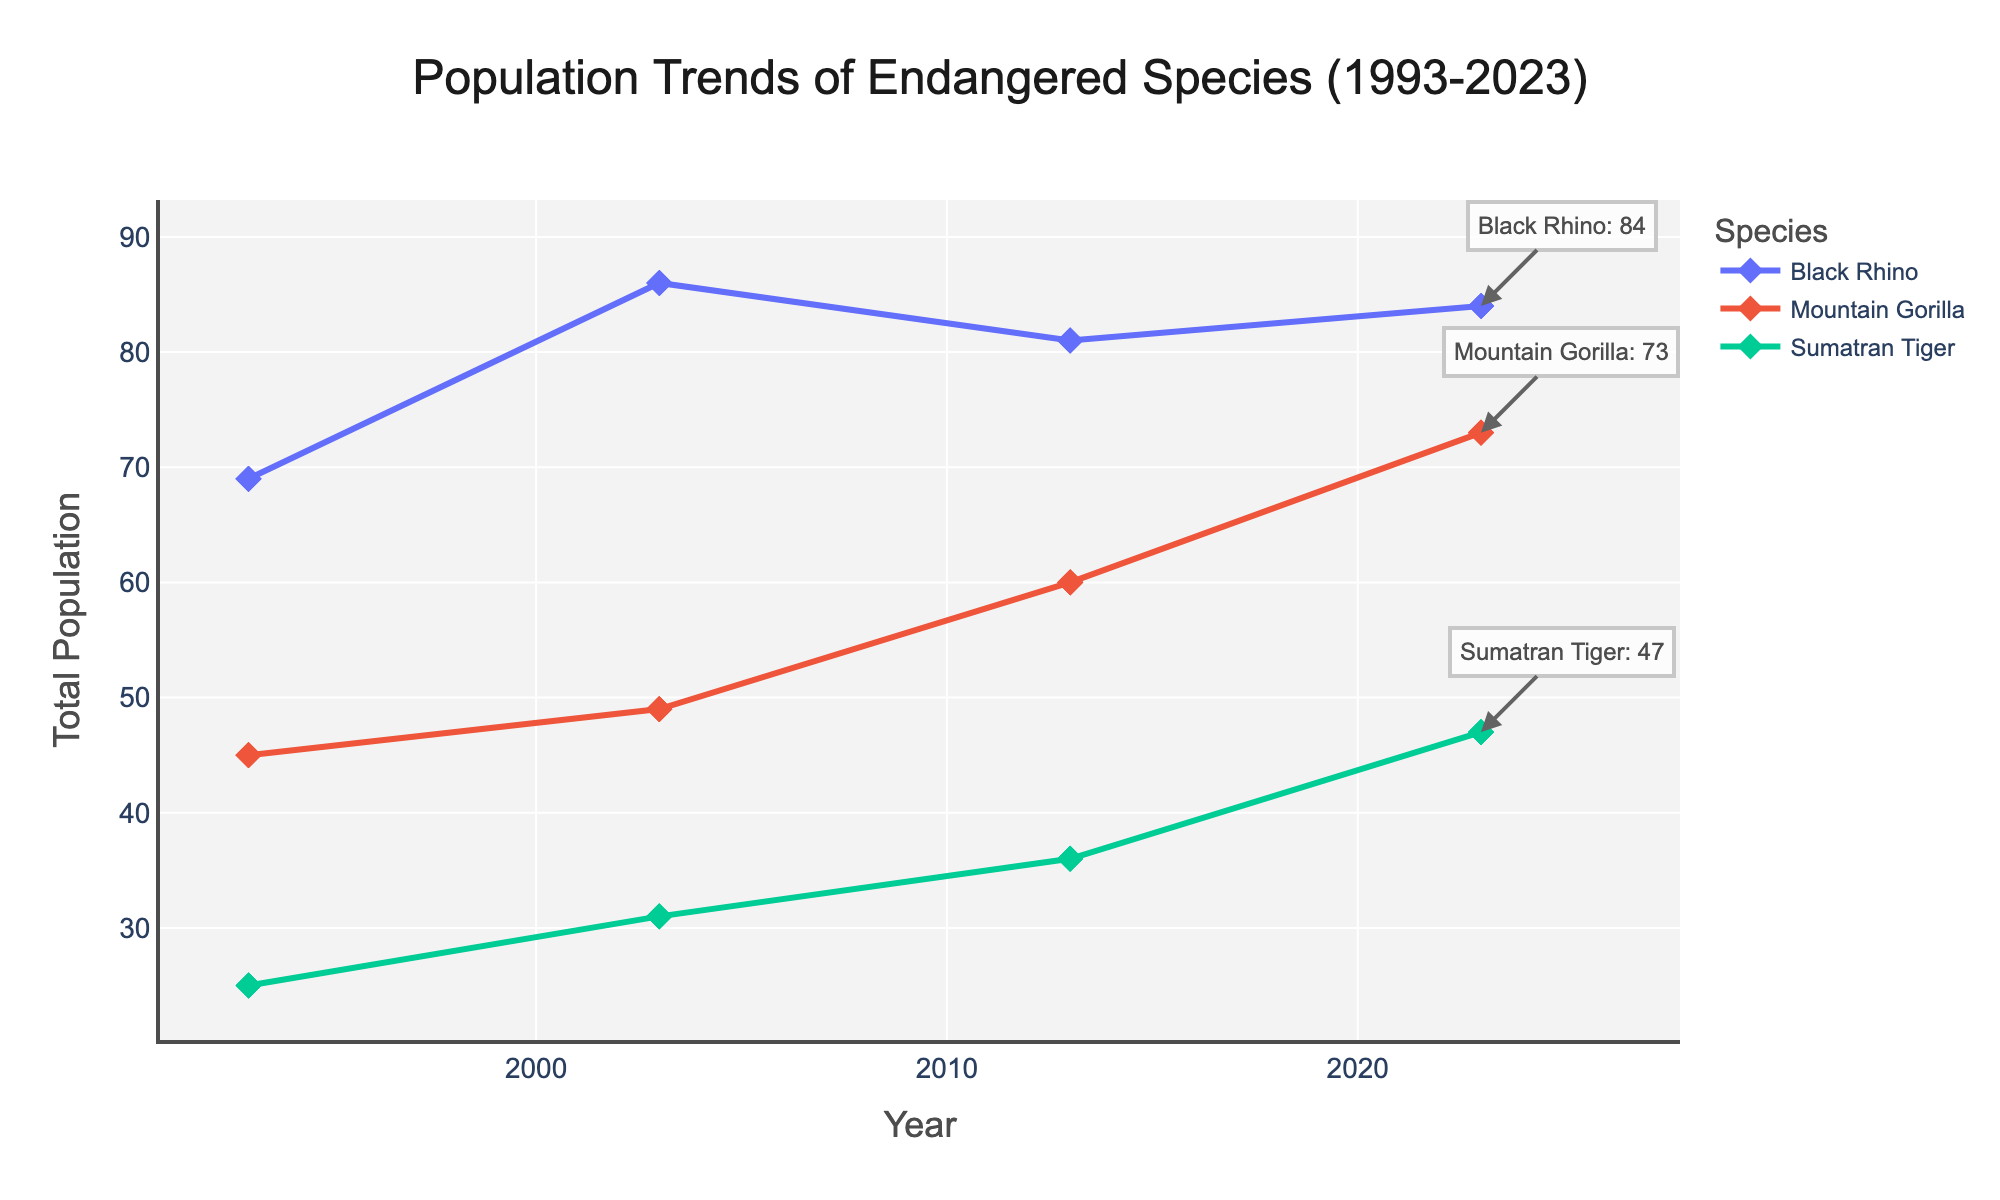What is the title of the figure? The title of the figure is displayed at the top and usually describes the main purpose or content of the figure. Here it reads, "Population Trends of Endangered Species (1993-2023)."
Answer: Population Trends of Endangered Species (1993-2023) How many species are tracked in this figure? The figure uses different colored lines with labels in the legend to represent each species. By counting the unique entries in the legend, it is clear that there are three species tracked.
Answer: Three species Which species had the highest total population in 2023? To determine this, look at the annotated end points of each line in 2023 and find the one with the highest value. The Mountain Gorilla has the highest annotation at 73.
Answer: Mountain Gorilla What was the total population of Sumatran Tigers in 1993? Look at the starting point of the Sumatran Tiger line marked at the year 1993 and check the y-axis value it corresponds to, which is annotated at 25.
Answer: 25 Compare the population trends of Black Rhinos and Mountain Gorillas. Which species showed a greater increase in population by 2023? To find this, compare the difference between the initial and final points of the lines for each species. Black Rhinos increased from around 69 to 84, and Mountain Gorillas from around 45 to 73. The Black Rhinos showed a greater increase (15) compared to Mountain Gorillas (28).
Answer: Black Rhinos What is the difference in total population between Mountain Gorillas and Black Rhinos in 2013? Check the figure for the total populations of both species in 2013. Mountain Gorillas are at 60, and Black Rhinos are at 81. Subtract to find the difference: 81 - 60 = 21.
Answer: 21 Which species had a declining population trend over one or more periods? To identify this, observe the trends of each species over the intervals (1993-2003, 2003-2013, 2013-2023). Sumatran Tigers saw no decreases, while Black Rhinos slightly decreased between 2003-2013 and Mountain Gorillas generally increased with minor fluctuations.
Answer: None of the species show a consistent decline By what percent did the Sumatran Tiger population increase from 1993 to 2023? Calculate the percentage increase. The initial population in 1993 is 25, and in 2023 it is 47. Use the formula: [(final - initial) / initial] * 100 = [(47 - 25) / 25] * 100 ≈ 88%.
Answer: Approximately 88% What is the mean total population of Black Rhinos from 1993 to 2023? Calculate the average population for Black Rhinos by summing their populations over the years and dividing by the number of years (1993, 2003, 2013, 2023). Sum: 69 + 86 + 81 + 84 = 320. Mean = 320 / 4 = 80.
Answer: 80 